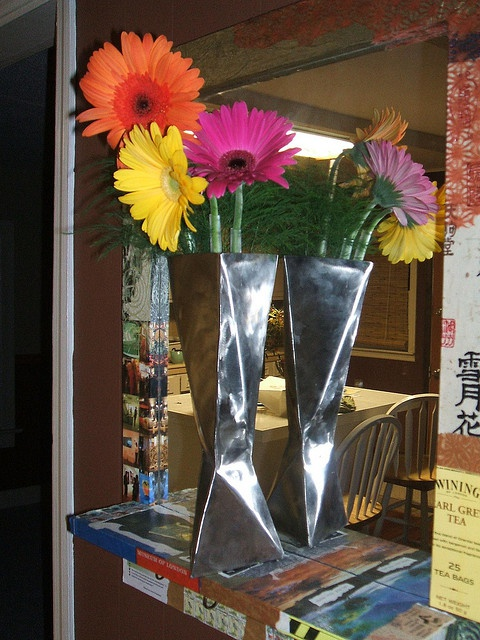Describe the objects in this image and their specific colors. I can see vase in black, gray, and white tones, vase in black, gray, white, and darkgray tones, chair in black, maroon, and olive tones, chair in black and gray tones, and dining table in black, olive, and tan tones in this image. 